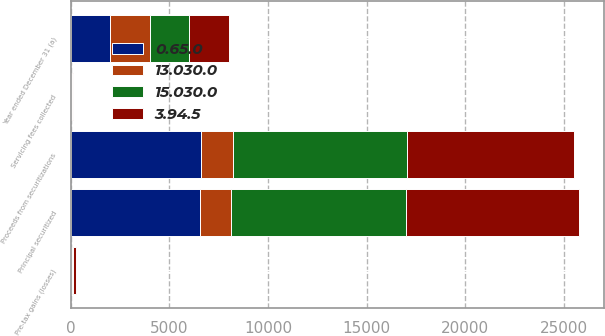<chart> <loc_0><loc_0><loc_500><loc_500><stacked_bar_chart><ecel><fcel>Year ended December 31 (a)<fcel>Principal securitized<fcel>Pre-tax gains (losses)<fcel>Proceeds from securitizations<fcel>Servicing fees collected<nl><fcel>0.65.0<fcel>2004<fcel>6529<fcel>47<fcel>6608<fcel>12<nl><fcel>15.030.0<fcel>2004<fcel>8850<fcel>52<fcel>8850<fcel>69<nl><fcel>13.030.0<fcel>2004<fcel>1600<fcel>3<fcel>1597<fcel>1<nl><fcel>3.94.5<fcel>2004<fcel>8756<fcel>135<fcel>8430<fcel>3<nl></chart> 